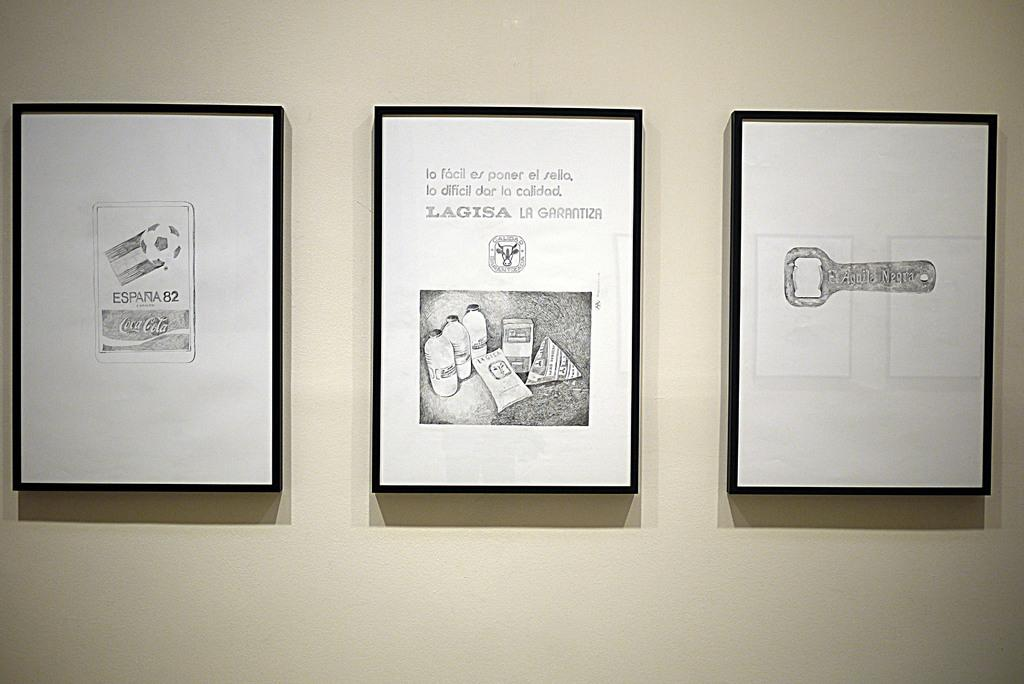Provide a one-sentence caption for the provided image. Three artworks with the subject of advertisement for Coca-cola, Lagisa and el aguila negra, respectively, are displayed on a wall. 